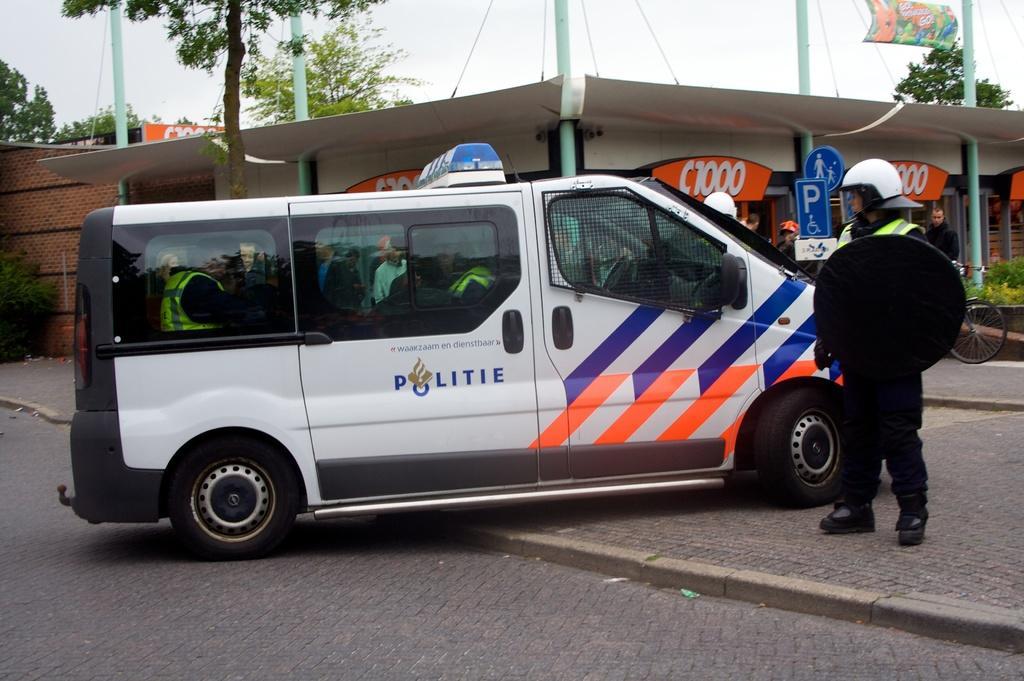In one or two sentences, can you explain what this image depicts? At the top we can see, pillars and trees. This is a hoarding. Here we can see wall with bricks. We can see one vehicle in front of the picture. a person standing near to the vehicle wearing helmet and holding a traffic board. 